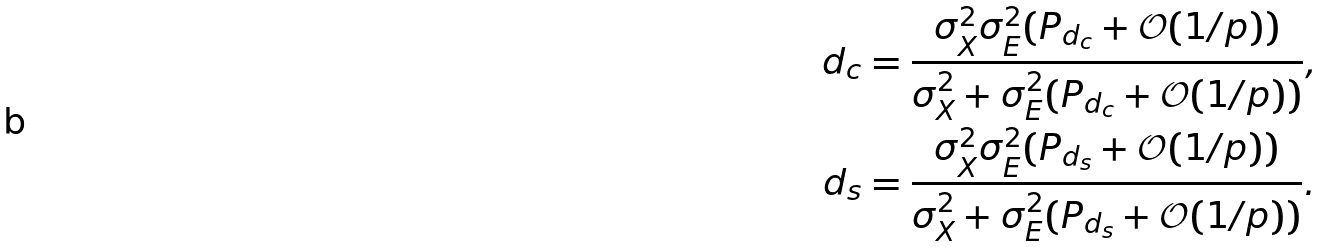Convert formula to latex. <formula><loc_0><loc_0><loc_500><loc_500>d _ { c } & = \frac { \sigma _ { X } ^ { 2 } \sigma _ { E } ^ { 2 } ( P _ { d _ { c } } + \mathcal { O } ( 1 / p ) ) } { \sigma _ { X } ^ { 2 } + \sigma _ { E } ^ { 2 } ( P _ { d _ { c } } + \mathcal { O } ( 1 / p ) ) } , \\ d _ { s } & = \frac { \sigma _ { X } ^ { 2 } \sigma _ { E } ^ { 2 } ( P _ { d _ { s } } + \mathcal { O } ( 1 / p ) ) } { \sigma _ { X } ^ { 2 } + \sigma _ { E } ^ { 2 } ( P _ { d _ { s } } + \mathcal { O } ( 1 / p ) ) } .</formula> 